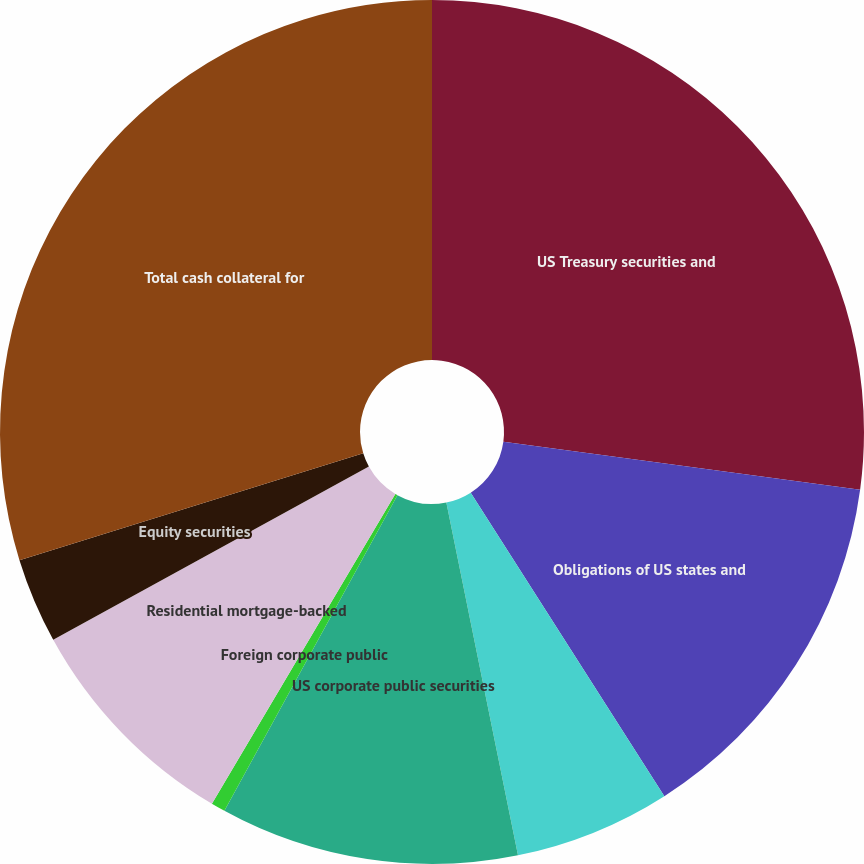Convert chart to OTSL. <chart><loc_0><loc_0><loc_500><loc_500><pie_chart><fcel>US Treasury securities and<fcel>Obligations of US states and<fcel>Foreign government bonds<fcel>US corporate public securities<fcel>Foreign corporate public<fcel>Residential mortgage-backed<fcel>Equity securities<fcel>Total cash collateral for<nl><fcel>27.14%<fcel>13.83%<fcel>5.85%<fcel>11.17%<fcel>0.53%<fcel>8.51%<fcel>3.19%<fcel>29.8%<nl></chart> 